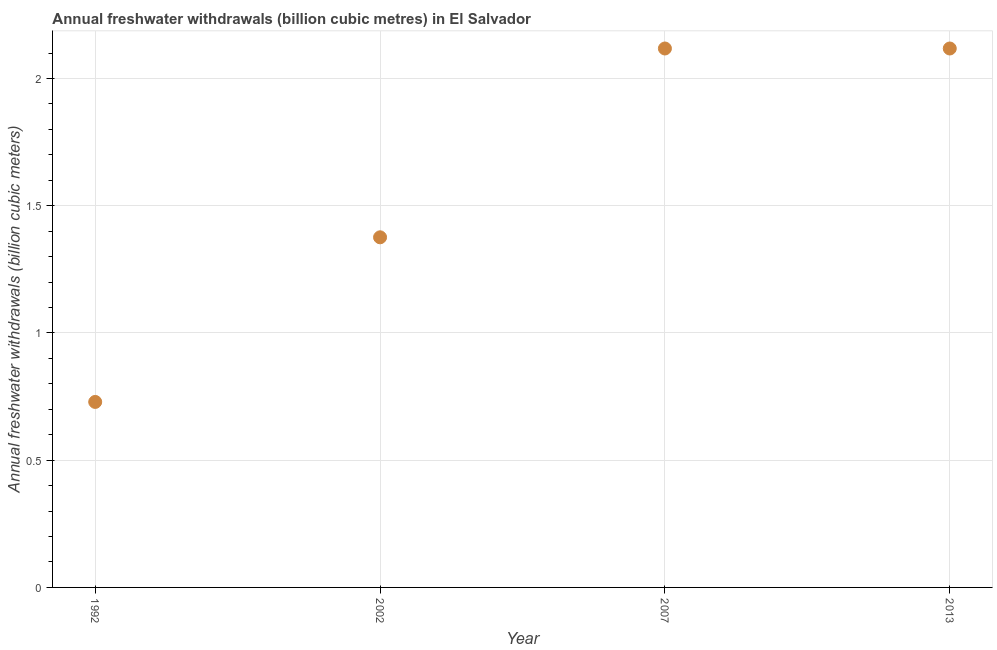What is the annual freshwater withdrawals in 2007?
Your answer should be very brief. 2.12. Across all years, what is the maximum annual freshwater withdrawals?
Offer a very short reply. 2.12. Across all years, what is the minimum annual freshwater withdrawals?
Ensure brevity in your answer.  0.73. What is the sum of the annual freshwater withdrawals?
Provide a succinct answer. 6.34. What is the difference between the annual freshwater withdrawals in 2002 and 2013?
Offer a very short reply. -0.74. What is the average annual freshwater withdrawals per year?
Give a very brief answer. 1.59. What is the median annual freshwater withdrawals?
Your response must be concise. 1.75. Do a majority of the years between 2013 and 2007 (inclusive) have annual freshwater withdrawals greater than 0.1 billion cubic meters?
Provide a short and direct response. No. What is the ratio of the annual freshwater withdrawals in 1992 to that in 2013?
Ensure brevity in your answer.  0.34. Is the difference between the annual freshwater withdrawals in 2007 and 2013 greater than the difference between any two years?
Offer a very short reply. No. What is the difference between the highest and the lowest annual freshwater withdrawals?
Offer a terse response. 1.39. How many dotlines are there?
Provide a short and direct response. 1. How many years are there in the graph?
Keep it short and to the point. 4. What is the difference between two consecutive major ticks on the Y-axis?
Offer a terse response. 0.5. Does the graph contain grids?
Ensure brevity in your answer.  Yes. What is the title of the graph?
Make the answer very short. Annual freshwater withdrawals (billion cubic metres) in El Salvador. What is the label or title of the Y-axis?
Your answer should be compact. Annual freshwater withdrawals (billion cubic meters). What is the Annual freshwater withdrawals (billion cubic meters) in 1992?
Keep it short and to the point. 0.73. What is the Annual freshwater withdrawals (billion cubic meters) in 2002?
Give a very brief answer. 1.38. What is the Annual freshwater withdrawals (billion cubic meters) in 2007?
Offer a very short reply. 2.12. What is the Annual freshwater withdrawals (billion cubic meters) in 2013?
Give a very brief answer. 2.12. What is the difference between the Annual freshwater withdrawals (billion cubic meters) in 1992 and 2002?
Give a very brief answer. -0.65. What is the difference between the Annual freshwater withdrawals (billion cubic meters) in 1992 and 2007?
Give a very brief answer. -1.39. What is the difference between the Annual freshwater withdrawals (billion cubic meters) in 1992 and 2013?
Your response must be concise. -1.39. What is the difference between the Annual freshwater withdrawals (billion cubic meters) in 2002 and 2007?
Make the answer very short. -0.74. What is the difference between the Annual freshwater withdrawals (billion cubic meters) in 2002 and 2013?
Offer a very short reply. -0.74. What is the ratio of the Annual freshwater withdrawals (billion cubic meters) in 1992 to that in 2002?
Your response must be concise. 0.53. What is the ratio of the Annual freshwater withdrawals (billion cubic meters) in 1992 to that in 2007?
Keep it short and to the point. 0.34. What is the ratio of the Annual freshwater withdrawals (billion cubic meters) in 1992 to that in 2013?
Offer a very short reply. 0.34. What is the ratio of the Annual freshwater withdrawals (billion cubic meters) in 2002 to that in 2007?
Provide a succinct answer. 0.65. What is the ratio of the Annual freshwater withdrawals (billion cubic meters) in 2002 to that in 2013?
Provide a succinct answer. 0.65. 